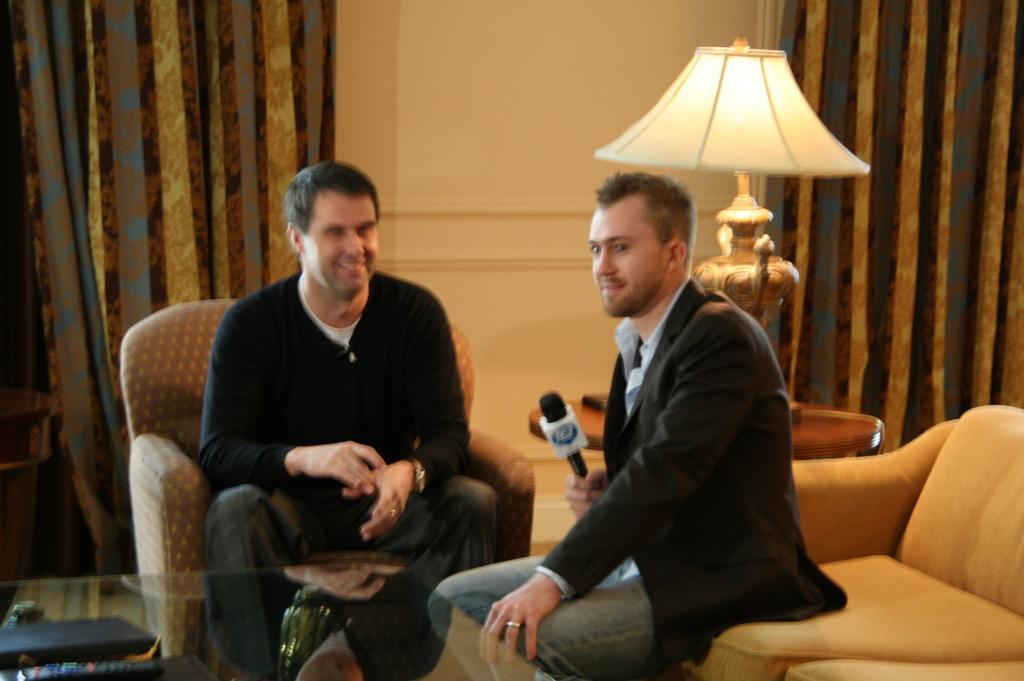Can you describe this image briefly? This picture shows two men seated on the chairs and a man holding microphone in his hand and we see a light and couple of curtains hanging 